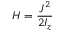<formula> <loc_0><loc_0><loc_500><loc_500>H = \frac { J ^ { 2 } } { 2 I _ { z } }</formula> 